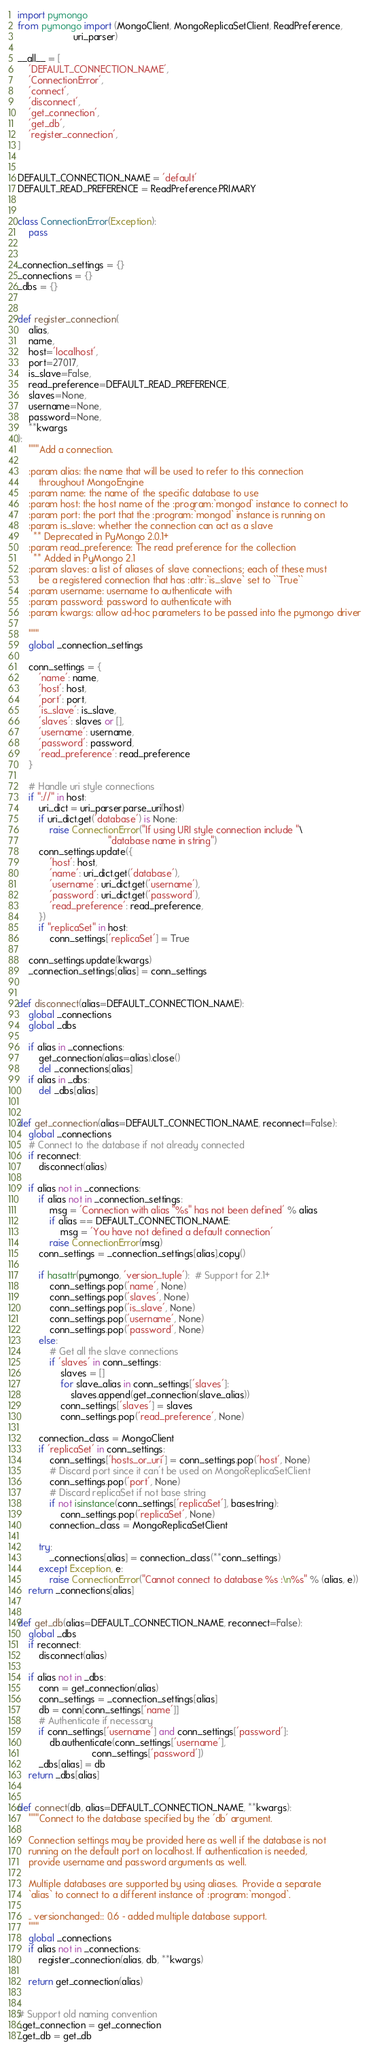<code> <loc_0><loc_0><loc_500><loc_500><_Python_>import pymongo
from pymongo import (MongoClient, MongoReplicaSetClient, ReadPreference,
                     uri_parser)

__all__ = [
    'DEFAULT_CONNECTION_NAME',
    'ConnectionError',
    'connect',
    'disconnect',
    'get_connection',
    'get_db',
    'register_connection',
]


DEFAULT_CONNECTION_NAME = 'default'
DEFAULT_READ_PREFERENCE = ReadPreference.PRIMARY


class ConnectionError(Exception):
    pass


_connection_settings = {}
_connections = {}
_dbs = {}


def register_connection(
    alias,
    name,
    host='localhost',
    port=27017,
    is_slave=False,
    read_preference=DEFAULT_READ_PREFERENCE,
    slaves=None,
    username=None,
    password=None,
    **kwargs
):
    """Add a connection.

    :param alias: the name that will be used to refer to this connection
        throughout MongoEngine
    :param name: the name of the specific database to use
    :param host: the host name of the :program:`mongod` instance to connect to
    :param port: the port that the :program:`mongod` instance is running on
    :param is_slave: whether the connection can act as a slave
      ** Deprecated in PyMongo 2.0.1+
    :param read_preference: The read preference for the collection
      ** Added in PyMongo 2.1
    :param slaves: a list of aliases of slave connections; each of these must
        be a registered connection that has :attr:`is_slave` set to ``True``
    :param username: username to authenticate with
    :param password: password to authenticate with
    :param kwargs: allow ad-hoc parameters to be passed into the pymongo driver

    """
    global _connection_settings

    conn_settings = {
        'name': name,
        'host': host,
        'port': port,
        'is_slave': is_slave,
        'slaves': slaves or [],
        'username': username,
        'password': password,
        'read_preference': read_preference
    }

    # Handle uri style connections
    if "://" in host:
        uri_dict = uri_parser.parse_uri(host)
        if uri_dict.get('database') is None:
            raise ConnectionError("If using URI style connection include "\
                                  "database name in string")
        conn_settings.update({
            'host': host,
            'name': uri_dict.get('database'),
            'username': uri_dict.get('username'),
            'password': uri_dict.get('password'),
            'read_preference': read_preference,
        })
        if "replicaSet" in host:
            conn_settings['replicaSet'] = True

    conn_settings.update(kwargs)
    _connection_settings[alias] = conn_settings


def disconnect(alias=DEFAULT_CONNECTION_NAME):
    global _connections
    global _dbs

    if alias in _connections:
        get_connection(alias=alias).close()
        del _connections[alias]
    if alias in _dbs:
        del _dbs[alias]


def get_connection(alias=DEFAULT_CONNECTION_NAME, reconnect=False):
    global _connections
    # Connect to the database if not already connected
    if reconnect:
        disconnect(alias)

    if alias not in _connections:
        if alias not in _connection_settings:
            msg = 'Connection with alias "%s" has not been defined' % alias
            if alias == DEFAULT_CONNECTION_NAME:
                msg = 'You have not defined a default connection'
            raise ConnectionError(msg)
        conn_settings = _connection_settings[alias].copy()

        if hasattr(pymongo, 'version_tuple'):  # Support for 2.1+
            conn_settings.pop('name', None)
            conn_settings.pop('slaves', None)
            conn_settings.pop('is_slave', None)
            conn_settings.pop('username', None)
            conn_settings.pop('password', None)
        else:
            # Get all the slave connections
            if 'slaves' in conn_settings:
                slaves = []
                for slave_alias in conn_settings['slaves']:
                    slaves.append(get_connection(slave_alias))
                conn_settings['slaves'] = slaves
                conn_settings.pop('read_preference', None)

        connection_class = MongoClient
        if 'replicaSet' in conn_settings:
            conn_settings['hosts_or_uri'] = conn_settings.pop('host', None)
            # Discard port since it can't be used on MongoReplicaSetClient
            conn_settings.pop('port', None)
            # Discard replicaSet if not base string
            if not isinstance(conn_settings['replicaSet'], basestring):
                conn_settings.pop('replicaSet', None)
            connection_class = MongoReplicaSetClient

        try:
            _connections[alias] = connection_class(**conn_settings)
        except Exception, e:
            raise ConnectionError("Cannot connect to database %s :\n%s" % (alias, e))
    return _connections[alias]


def get_db(alias=DEFAULT_CONNECTION_NAME, reconnect=False):
    global _dbs
    if reconnect:
        disconnect(alias)

    if alias not in _dbs:
        conn = get_connection(alias)
        conn_settings = _connection_settings[alias]
        db = conn[conn_settings['name']]
        # Authenticate if necessary
        if conn_settings['username'] and conn_settings['password']:
            db.authenticate(conn_settings['username'],
                            conn_settings['password'])
        _dbs[alias] = db
    return _dbs[alias]


def connect(db, alias=DEFAULT_CONNECTION_NAME, **kwargs):
    """Connect to the database specified by the 'db' argument.

    Connection settings may be provided here as well if the database is not
    running on the default port on localhost. If authentication is needed,
    provide username and password arguments as well.

    Multiple databases are supported by using aliases.  Provide a separate
    `alias` to connect to a different instance of :program:`mongod`.

    .. versionchanged:: 0.6 - added multiple database support.
    """
    global _connections
    if alias not in _connections:
        register_connection(alias, db, **kwargs)

    return get_connection(alias)


# Support old naming convention
_get_connection = get_connection
_get_db = get_db
</code> 